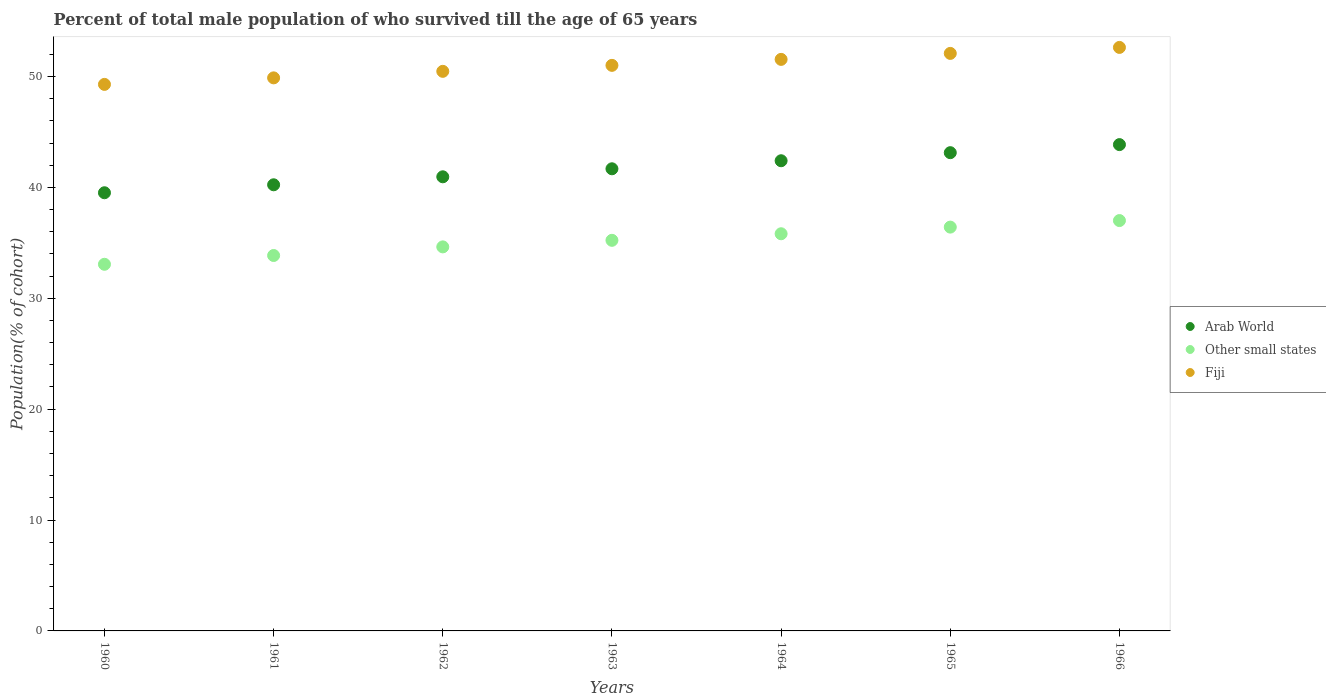Is the number of dotlines equal to the number of legend labels?
Give a very brief answer. Yes. What is the percentage of total male population who survived till the age of 65 years in Arab World in 1963?
Provide a succinct answer. 41.68. Across all years, what is the maximum percentage of total male population who survived till the age of 65 years in Arab World?
Provide a succinct answer. 43.86. Across all years, what is the minimum percentage of total male population who survived till the age of 65 years in Arab World?
Your response must be concise. 39.52. In which year was the percentage of total male population who survived till the age of 65 years in Fiji maximum?
Offer a very short reply. 1966. What is the total percentage of total male population who survived till the age of 65 years in Fiji in the graph?
Your answer should be very brief. 356.89. What is the difference between the percentage of total male population who survived till the age of 65 years in Arab World in 1965 and that in 1966?
Offer a very short reply. -0.73. What is the difference between the percentage of total male population who survived till the age of 65 years in Other small states in 1961 and the percentage of total male population who survived till the age of 65 years in Arab World in 1963?
Make the answer very short. -7.82. What is the average percentage of total male population who survived till the age of 65 years in Fiji per year?
Ensure brevity in your answer.  50.98. In the year 1963, what is the difference between the percentage of total male population who survived till the age of 65 years in Arab World and percentage of total male population who survived till the age of 65 years in Other small states?
Your response must be concise. 6.45. What is the ratio of the percentage of total male population who survived till the age of 65 years in Other small states in 1961 to that in 1965?
Make the answer very short. 0.93. Is the percentage of total male population who survived till the age of 65 years in Fiji in 1965 less than that in 1966?
Provide a short and direct response. Yes. What is the difference between the highest and the second highest percentage of total male population who survived till the age of 65 years in Arab World?
Keep it short and to the point. 0.73. What is the difference between the highest and the lowest percentage of total male population who survived till the age of 65 years in Other small states?
Keep it short and to the point. 3.94. In how many years, is the percentage of total male population who survived till the age of 65 years in Arab World greater than the average percentage of total male population who survived till the age of 65 years in Arab World taken over all years?
Make the answer very short. 3. Is the percentage of total male population who survived till the age of 65 years in Arab World strictly greater than the percentage of total male population who survived till the age of 65 years in Fiji over the years?
Ensure brevity in your answer.  No. How many dotlines are there?
Give a very brief answer. 3. What is the difference between two consecutive major ticks on the Y-axis?
Make the answer very short. 10. Are the values on the major ticks of Y-axis written in scientific E-notation?
Your answer should be compact. No. Does the graph contain any zero values?
Provide a short and direct response. No. Does the graph contain grids?
Your answer should be very brief. No. Where does the legend appear in the graph?
Your response must be concise. Center right. What is the title of the graph?
Ensure brevity in your answer.  Percent of total male population of who survived till the age of 65 years. Does "Lithuania" appear as one of the legend labels in the graph?
Provide a short and direct response. No. What is the label or title of the X-axis?
Your answer should be very brief. Years. What is the label or title of the Y-axis?
Provide a succinct answer. Population(% of cohort). What is the Population(% of cohort) of Arab World in 1960?
Offer a terse response. 39.52. What is the Population(% of cohort) of Other small states in 1960?
Provide a succinct answer. 33.07. What is the Population(% of cohort) of Fiji in 1960?
Your response must be concise. 49.29. What is the Population(% of cohort) in Arab World in 1961?
Provide a succinct answer. 40.23. What is the Population(% of cohort) of Other small states in 1961?
Provide a succinct answer. 33.86. What is the Population(% of cohort) in Fiji in 1961?
Ensure brevity in your answer.  49.88. What is the Population(% of cohort) in Arab World in 1962?
Keep it short and to the point. 40.96. What is the Population(% of cohort) in Other small states in 1962?
Make the answer very short. 34.64. What is the Population(% of cohort) in Fiji in 1962?
Keep it short and to the point. 50.47. What is the Population(% of cohort) of Arab World in 1963?
Your answer should be very brief. 41.68. What is the Population(% of cohort) of Other small states in 1963?
Offer a terse response. 35.23. What is the Population(% of cohort) in Fiji in 1963?
Ensure brevity in your answer.  51.01. What is the Population(% of cohort) of Arab World in 1964?
Keep it short and to the point. 42.4. What is the Population(% of cohort) in Other small states in 1964?
Ensure brevity in your answer.  35.82. What is the Population(% of cohort) of Fiji in 1964?
Offer a very short reply. 51.54. What is the Population(% of cohort) in Arab World in 1965?
Keep it short and to the point. 43.13. What is the Population(% of cohort) of Other small states in 1965?
Ensure brevity in your answer.  36.42. What is the Population(% of cohort) of Fiji in 1965?
Give a very brief answer. 52.08. What is the Population(% of cohort) in Arab World in 1966?
Make the answer very short. 43.86. What is the Population(% of cohort) in Other small states in 1966?
Offer a terse response. 37.01. What is the Population(% of cohort) of Fiji in 1966?
Your response must be concise. 52.62. Across all years, what is the maximum Population(% of cohort) of Arab World?
Your response must be concise. 43.86. Across all years, what is the maximum Population(% of cohort) in Other small states?
Ensure brevity in your answer.  37.01. Across all years, what is the maximum Population(% of cohort) in Fiji?
Keep it short and to the point. 52.62. Across all years, what is the minimum Population(% of cohort) of Arab World?
Your response must be concise. 39.52. Across all years, what is the minimum Population(% of cohort) in Other small states?
Provide a succinct answer. 33.07. Across all years, what is the minimum Population(% of cohort) in Fiji?
Provide a short and direct response. 49.29. What is the total Population(% of cohort) of Arab World in the graph?
Make the answer very short. 291.78. What is the total Population(% of cohort) of Other small states in the graph?
Give a very brief answer. 246.03. What is the total Population(% of cohort) of Fiji in the graph?
Make the answer very short. 356.89. What is the difference between the Population(% of cohort) in Arab World in 1960 and that in 1961?
Your answer should be compact. -0.72. What is the difference between the Population(% of cohort) in Other small states in 1960 and that in 1961?
Offer a terse response. -0.79. What is the difference between the Population(% of cohort) of Fiji in 1960 and that in 1961?
Your response must be concise. -0.59. What is the difference between the Population(% of cohort) of Arab World in 1960 and that in 1962?
Make the answer very short. -1.44. What is the difference between the Population(% of cohort) of Other small states in 1960 and that in 1962?
Your response must be concise. -1.57. What is the difference between the Population(% of cohort) of Fiji in 1960 and that in 1962?
Your answer should be compact. -1.18. What is the difference between the Population(% of cohort) of Arab World in 1960 and that in 1963?
Offer a terse response. -2.16. What is the difference between the Population(% of cohort) of Other small states in 1960 and that in 1963?
Make the answer very short. -2.16. What is the difference between the Population(% of cohort) of Fiji in 1960 and that in 1963?
Keep it short and to the point. -1.72. What is the difference between the Population(% of cohort) in Arab World in 1960 and that in 1964?
Offer a very short reply. -2.89. What is the difference between the Population(% of cohort) in Other small states in 1960 and that in 1964?
Provide a succinct answer. -2.75. What is the difference between the Population(% of cohort) of Fiji in 1960 and that in 1964?
Provide a short and direct response. -2.26. What is the difference between the Population(% of cohort) of Arab World in 1960 and that in 1965?
Make the answer very short. -3.61. What is the difference between the Population(% of cohort) in Other small states in 1960 and that in 1965?
Your answer should be compact. -3.35. What is the difference between the Population(% of cohort) of Fiji in 1960 and that in 1965?
Your answer should be very brief. -2.8. What is the difference between the Population(% of cohort) in Arab World in 1960 and that in 1966?
Your answer should be very brief. -4.34. What is the difference between the Population(% of cohort) of Other small states in 1960 and that in 1966?
Offer a very short reply. -3.94. What is the difference between the Population(% of cohort) of Fiji in 1960 and that in 1966?
Give a very brief answer. -3.33. What is the difference between the Population(% of cohort) in Arab World in 1961 and that in 1962?
Keep it short and to the point. -0.72. What is the difference between the Population(% of cohort) of Other small states in 1961 and that in 1962?
Keep it short and to the point. -0.78. What is the difference between the Population(% of cohort) of Fiji in 1961 and that in 1962?
Offer a very short reply. -0.59. What is the difference between the Population(% of cohort) in Arab World in 1961 and that in 1963?
Your response must be concise. -1.44. What is the difference between the Population(% of cohort) in Other small states in 1961 and that in 1963?
Your response must be concise. -1.37. What is the difference between the Population(% of cohort) in Fiji in 1961 and that in 1963?
Your response must be concise. -1.13. What is the difference between the Population(% of cohort) of Arab World in 1961 and that in 1964?
Make the answer very short. -2.17. What is the difference between the Population(% of cohort) in Other small states in 1961 and that in 1964?
Your response must be concise. -1.96. What is the difference between the Population(% of cohort) in Fiji in 1961 and that in 1964?
Your answer should be compact. -1.67. What is the difference between the Population(% of cohort) of Arab World in 1961 and that in 1965?
Your response must be concise. -2.9. What is the difference between the Population(% of cohort) in Other small states in 1961 and that in 1965?
Keep it short and to the point. -2.56. What is the difference between the Population(% of cohort) of Fiji in 1961 and that in 1965?
Your answer should be compact. -2.21. What is the difference between the Population(% of cohort) in Arab World in 1961 and that in 1966?
Give a very brief answer. -3.62. What is the difference between the Population(% of cohort) of Other small states in 1961 and that in 1966?
Your answer should be compact. -3.15. What is the difference between the Population(% of cohort) of Fiji in 1961 and that in 1966?
Your answer should be compact. -2.75. What is the difference between the Population(% of cohort) of Arab World in 1962 and that in 1963?
Your answer should be compact. -0.72. What is the difference between the Population(% of cohort) of Other small states in 1962 and that in 1963?
Offer a terse response. -0.59. What is the difference between the Population(% of cohort) of Fiji in 1962 and that in 1963?
Provide a short and direct response. -0.54. What is the difference between the Population(% of cohort) of Arab World in 1962 and that in 1964?
Offer a very short reply. -1.45. What is the difference between the Population(% of cohort) of Other small states in 1962 and that in 1964?
Keep it short and to the point. -1.18. What is the difference between the Population(% of cohort) of Fiji in 1962 and that in 1964?
Provide a short and direct response. -1.08. What is the difference between the Population(% of cohort) of Arab World in 1962 and that in 1965?
Your response must be concise. -2.18. What is the difference between the Population(% of cohort) in Other small states in 1962 and that in 1965?
Ensure brevity in your answer.  -1.78. What is the difference between the Population(% of cohort) of Fiji in 1962 and that in 1965?
Your answer should be compact. -1.62. What is the difference between the Population(% of cohort) in Arab World in 1962 and that in 1966?
Offer a terse response. -2.9. What is the difference between the Population(% of cohort) in Other small states in 1962 and that in 1966?
Your response must be concise. -2.37. What is the difference between the Population(% of cohort) of Fiji in 1962 and that in 1966?
Your answer should be very brief. -2.16. What is the difference between the Population(% of cohort) in Arab World in 1963 and that in 1964?
Your response must be concise. -0.72. What is the difference between the Population(% of cohort) of Other small states in 1963 and that in 1964?
Provide a short and direct response. -0.59. What is the difference between the Population(% of cohort) of Fiji in 1963 and that in 1964?
Offer a terse response. -0.54. What is the difference between the Population(% of cohort) of Arab World in 1963 and that in 1965?
Provide a succinct answer. -1.45. What is the difference between the Population(% of cohort) in Other small states in 1963 and that in 1965?
Make the answer very short. -1.19. What is the difference between the Population(% of cohort) in Fiji in 1963 and that in 1965?
Ensure brevity in your answer.  -1.08. What is the difference between the Population(% of cohort) in Arab World in 1963 and that in 1966?
Your response must be concise. -2.18. What is the difference between the Population(% of cohort) of Other small states in 1963 and that in 1966?
Your response must be concise. -1.78. What is the difference between the Population(% of cohort) of Fiji in 1963 and that in 1966?
Provide a short and direct response. -1.62. What is the difference between the Population(% of cohort) of Arab World in 1964 and that in 1965?
Make the answer very short. -0.73. What is the difference between the Population(% of cohort) of Other small states in 1964 and that in 1965?
Make the answer very short. -0.6. What is the difference between the Population(% of cohort) in Fiji in 1964 and that in 1965?
Your answer should be very brief. -0.54. What is the difference between the Population(% of cohort) of Arab World in 1964 and that in 1966?
Provide a succinct answer. -1.46. What is the difference between the Population(% of cohort) of Other small states in 1964 and that in 1966?
Make the answer very short. -1.19. What is the difference between the Population(% of cohort) of Fiji in 1964 and that in 1966?
Provide a succinct answer. -1.08. What is the difference between the Population(% of cohort) in Arab World in 1965 and that in 1966?
Your response must be concise. -0.73. What is the difference between the Population(% of cohort) of Other small states in 1965 and that in 1966?
Offer a very short reply. -0.59. What is the difference between the Population(% of cohort) of Fiji in 1965 and that in 1966?
Your answer should be compact. -0.54. What is the difference between the Population(% of cohort) in Arab World in 1960 and the Population(% of cohort) in Other small states in 1961?
Make the answer very short. 5.66. What is the difference between the Population(% of cohort) in Arab World in 1960 and the Population(% of cohort) in Fiji in 1961?
Offer a terse response. -10.36. What is the difference between the Population(% of cohort) in Other small states in 1960 and the Population(% of cohort) in Fiji in 1961?
Make the answer very short. -16.81. What is the difference between the Population(% of cohort) in Arab World in 1960 and the Population(% of cohort) in Other small states in 1962?
Your answer should be compact. 4.88. What is the difference between the Population(% of cohort) of Arab World in 1960 and the Population(% of cohort) of Fiji in 1962?
Give a very brief answer. -10.95. What is the difference between the Population(% of cohort) in Other small states in 1960 and the Population(% of cohort) in Fiji in 1962?
Your answer should be very brief. -17.4. What is the difference between the Population(% of cohort) of Arab World in 1960 and the Population(% of cohort) of Other small states in 1963?
Make the answer very short. 4.29. What is the difference between the Population(% of cohort) of Arab World in 1960 and the Population(% of cohort) of Fiji in 1963?
Ensure brevity in your answer.  -11.49. What is the difference between the Population(% of cohort) of Other small states in 1960 and the Population(% of cohort) of Fiji in 1963?
Make the answer very short. -17.94. What is the difference between the Population(% of cohort) of Arab World in 1960 and the Population(% of cohort) of Other small states in 1964?
Make the answer very short. 3.7. What is the difference between the Population(% of cohort) of Arab World in 1960 and the Population(% of cohort) of Fiji in 1964?
Give a very brief answer. -12.03. What is the difference between the Population(% of cohort) in Other small states in 1960 and the Population(% of cohort) in Fiji in 1964?
Make the answer very short. -18.48. What is the difference between the Population(% of cohort) of Arab World in 1960 and the Population(% of cohort) of Other small states in 1965?
Your answer should be very brief. 3.1. What is the difference between the Population(% of cohort) of Arab World in 1960 and the Population(% of cohort) of Fiji in 1965?
Provide a short and direct response. -12.57. What is the difference between the Population(% of cohort) in Other small states in 1960 and the Population(% of cohort) in Fiji in 1965?
Your answer should be compact. -19.02. What is the difference between the Population(% of cohort) of Arab World in 1960 and the Population(% of cohort) of Other small states in 1966?
Offer a terse response. 2.51. What is the difference between the Population(% of cohort) of Arab World in 1960 and the Population(% of cohort) of Fiji in 1966?
Keep it short and to the point. -13.11. What is the difference between the Population(% of cohort) of Other small states in 1960 and the Population(% of cohort) of Fiji in 1966?
Offer a terse response. -19.56. What is the difference between the Population(% of cohort) of Arab World in 1961 and the Population(% of cohort) of Other small states in 1962?
Offer a very short reply. 5.6. What is the difference between the Population(% of cohort) in Arab World in 1961 and the Population(% of cohort) in Fiji in 1962?
Provide a succinct answer. -10.23. What is the difference between the Population(% of cohort) of Other small states in 1961 and the Population(% of cohort) of Fiji in 1962?
Your response must be concise. -16.61. What is the difference between the Population(% of cohort) in Arab World in 1961 and the Population(% of cohort) in Other small states in 1963?
Your answer should be very brief. 5.01. What is the difference between the Population(% of cohort) of Arab World in 1961 and the Population(% of cohort) of Fiji in 1963?
Your answer should be compact. -10.77. What is the difference between the Population(% of cohort) of Other small states in 1961 and the Population(% of cohort) of Fiji in 1963?
Keep it short and to the point. -17.15. What is the difference between the Population(% of cohort) in Arab World in 1961 and the Population(% of cohort) in Other small states in 1964?
Make the answer very short. 4.42. What is the difference between the Population(% of cohort) in Arab World in 1961 and the Population(% of cohort) in Fiji in 1964?
Your answer should be compact. -11.31. What is the difference between the Population(% of cohort) of Other small states in 1961 and the Population(% of cohort) of Fiji in 1964?
Provide a short and direct response. -17.69. What is the difference between the Population(% of cohort) of Arab World in 1961 and the Population(% of cohort) of Other small states in 1965?
Your response must be concise. 3.82. What is the difference between the Population(% of cohort) of Arab World in 1961 and the Population(% of cohort) of Fiji in 1965?
Keep it short and to the point. -11.85. What is the difference between the Population(% of cohort) in Other small states in 1961 and the Population(% of cohort) in Fiji in 1965?
Offer a very short reply. -18.23. What is the difference between the Population(% of cohort) in Arab World in 1961 and the Population(% of cohort) in Other small states in 1966?
Offer a terse response. 3.23. What is the difference between the Population(% of cohort) in Arab World in 1961 and the Population(% of cohort) in Fiji in 1966?
Provide a succinct answer. -12.39. What is the difference between the Population(% of cohort) of Other small states in 1961 and the Population(% of cohort) of Fiji in 1966?
Offer a very short reply. -18.77. What is the difference between the Population(% of cohort) in Arab World in 1962 and the Population(% of cohort) in Other small states in 1963?
Offer a very short reply. 5.73. What is the difference between the Population(% of cohort) in Arab World in 1962 and the Population(% of cohort) in Fiji in 1963?
Your answer should be compact. -10.05. What is the difference between the Population(% of cohort) of Other small states in 1962 and the Population(% of cohort) of Fiji in 1963?
Your answer should be compact. -16.37. What is the difference between the Population(% of cohort) of Arab World in 1962 and the Population(% of cohort) of Other small states in 1964?
Ensure brevity in your answer.  5.14. What is the difference between the Population(% of cohort) of Arab World in 1962 and the Population(% of cohort) of Fiji in 1964?
Make the answer very short. -10.59. What is the difference between the Population(% of cohort) in Other small states in 1962 and the Population(% of cohort) in Fiji in 1964?
Provide a succinct answer. -16.91. What is the difference between the Population(% of cohort) in Arab World in 1962 and the Population(% of cohort) in Other small states in 1965?
Your answer should be very brief. 4.54. What is the difference between the Population(% of cohort) in Arab World in 1962 and the Population(% of cohort) in Fiji in 1965?
Ensure brevity in your answer.  -11.13. What is the difference between the Population(% of cohort) in Other small states in 1962 and the Population(% of cohort) in Fiji in 1965?
Keep it short and to the point. -17.45. What is the difference between the Population(% of cohort) of Arab World in 1962 and the Population(% of cohort) of Other small states in 1966?
Ensure brevity in your answer.  3.95. What is the difference between the Population(% of cohort) of Arab World in 1962 and the Population(% of cohort) of Fiji in 1966?
Give a very brief answer. -11.67. What is the difference between the Population(% of cohort) in Other small states in 1962 and the Population(% of cohort) in Fiji in 1966?
Give a very brief answer. -17.99. What is the difference between the Population(% of cohort) of Arab World in 1963 and the Population(% of cohort) of Other small states in 1964?
Offer a terse response. 5.86. What is the difference between the Population(% of cohort) in Arab World in 1963 and the Population(% of cohort) in Fiji in 1964?
Your response must be concise. -9.87. What is the difference between the Population(% of cohort) of Other small states in 1963 and the Population(% of cohort) of Fiji in 1964?
Your response must be concise. -16.32. What is the difference between the Population(% of cohort) of Arab World in 1963 and the Population(% of cohort) of Other small states in 1965?
Provide a succinct answer. 5.26. What is the difference between the Population(% of cohort) in Arab World in 1963 and the Population(% of cohort) in Fiji in 1965?
Your response must be concise. -10.41. What is the difference between the Population(% of cohort) in Other small states in 1963 and the Population(% of cohort) in Fiji in 1965?
Your answer should be very brief. -16.86. What is the difference between the Population(% of cohort) of Arab World in 1963 and the Population(% of cohort) of Other small states in 1966?
Give a very brief answer. 4.67. What is the difference between the Population(% of cohort) in Arab World in 1963 and the Population(% of cohort) in Fiji in 1966?
Make the answer very short. -10.95. What is the difference between the Population(% of cohort) in Other small states in 1963 and the Population(% of cohort) in Fiji in 1966?
Make the answer very short. -17.4. What is the difference between the Population(% of cohort) in Arab World in 1964 and the Population(% of cohort) in Other small states in 1965?
Your answer should be very brief. 5.99. What is the difference between the Population(% of cohort) of Arab World in 1964 and the Population(% of cohort) of Fiji in 1965?
Provide a succinct answer. -9.68. What is the difference between the Population(% of cohort) in Other small states in 1964 and the Population(% of cohort) in Fiji in 1965?
Keep it short and to the point. -16.27. What is the difference between the Population(% of cohort) of Arab World in 1964 and the Population(% of cohort) of Other small states in 1966?
Provide a succinct answer. 5.39. What is the difference between the Population(% of cohort) of Arab World in 1964 and the Population(% of cohort) of Fiji in 1966?
Offer a terse response. -10.22. What is the difference between the Population(% of cohort) of Other small states in 1964 and the Population(% of cohort) of Fiji in 1966?
Your answer should be compact. -16.81. What is the difference between the Population(% of cohort) of Arab World in 1965 and the Population(% of cohort) of Other small states in 1966?
Offer a terse response. 6.12. What is the difference between the Population(% of cohort) in Arab World in 1965 and the Population(% of cohort) in Fiji in 1966?
Your response must be concise. -9.49. What is the difference between the Population(% of cohort) in Other small states in 1965 and the Population(% of cohort) in Fiji in 1966?
Your answer should be very brief. -16.21. What is the average Population(% of cohort) in Arab World per year?
Your answer should be compact. 41.68. What is the average Population(% of cohort) of Other small states per year?
Give a very brief answer. 35.15. What is the average Population(% of cohort) in Fiji per year?
Offer a terse response. 50.98. In the year 1960, what is the difference between the Population(% of cohort) in Arab World and Population(% of cohort) in Other small states?
Give a very brief answer. 6.45. In the year 1960, what is the difference between the Population(% of cohort) in Arab World and Population(% of cohort) in Fiji?
Make the answer very short. -9.77. In the year 1960, what is the difference between the Population(% of cohort) in Other small states and Population(% of cohort) in Fiji?
Your response must be concise. -16.22. In the year 1961, what is the difference between the Population(% of cohort) in Arab World and Population(% of cohort) in Other small states?
Your answer should be compact. 6.38. In the year 1961, what is the difference between the Population(% of cohort) in Arab World and Population(% of cohort) in Fiji?
Your answer should be compact. -9.64. In the year 1961, what is the difference between the Population(% of cohort) in Other small states and Population(% of cohort) in Fiji?
Provide a short and direct response. -16.02. In the year 1962, what is the difference between the Population(% of cohort) of Arab World and Population(% of cohort) of Other small states?
Give a very brief answer. 6.32. In the year 1962, what is the difference between the Population(% of cohort) of Arab World and Population(% of cohort) of Fiji?
Make the answer very short. -9.51. In the year 1962, what is the difference between the Population(% of cohort) of Other small states and Population(% of cohort) of Fiji?
Give a very brief answer. -15.83. In the year 1963, what is the difference between the Population(% of cohort) of Arab World and Population(% of cohort) of Other small states?
Give a very brief answer. 6.45. In the year 1963, what is the difference between the Population(% of cohort) in Arab World and Population(% of cohort) in Fiji?
Make the answer very short. -9.33. In the year 1963, what is the difference between the Population(% of cohort) in Other small states and Population(% of cohort) in Fiji?
Provide a succinct answer. -15.78. In the year 1964, what is the difference between the Population(% of cohort) of Arab World and Population(% of cohort) of Other small states?
Your response must be concise. 6.58. In the year 1964, what is the difference between the Population(% of cohort) in Arab World and Population(% of cohort) in Fiji?
Keep it short and to the point. -9.14. In the year 1964, what is the difference between the Population(% of cohort) in Other small states and Population(% of cohort) in Fiji?
Your response must be concise. -15.73. In the year 1965, what is the difference between the Population(% of cohort) of Arab World and Population(% of cohort) of Other small states?
Keep it short and to the point. 6.71. In the year 1965, what is the difference between the Population(% of cohort) in Arab World and Population(% of cohort) in Fiji?
Offer a terse response. -8.95. In the year 1965, what is the difference between the Population(% of cohort) of Other small states and Population(% of cohort) of Fiji?
Make the answer very short. -15.67. In the year 1966, what is the difference between the Population(% of cohort) in Arab World and Population(% of cohort) in Other small states?
Offer a very short reply. 6.85. In the year 1966, what is the difference between the Population(% of cohort) of Arab World and Population(% of cohort) of Fiji?
Provide a succinct answer. -8.77. In the year 1966, what is the difference between the Population(% of cohort) of Other small states and Population(% of cohort) of Fiji?
Ensure brevity in your answer.  -15.62. What is the ratio of the Population(% of cohort) of Arab World in 1960 to that in 1961?
Offer a very short reply. 0.98. What is the ratio of the Population(% of cohort) in Other small states in 1960 to that in 1961?
Offer a very short reply. 0.98. What is the ratio of the Population(% of cohort) in Arab World in 1960 to that in 1962?
Keep it short and to the point. 0.96. What is the ratio of the Population(% of cohort) in Other small states in 1960 to that in 1962?
Keep it short and to the point. 0.95. What is the ratio of the Population(% of cohort) in Fiji in 1960 to that in 1962?
Make the answer very short. 0.98. What is the ratio of the Population(% of cohort) of Arab World in 1960 to that in 1963?
Make the answer very short. 0.95. What is the ratio of the Population(% of cohort) of Other small states in 1960 to that in 1963?
Ensure brevity in your answer.  0.94. What is the ratio of the Population(% of cohort) of Fiji in 1960 to that in 1963?
Your response must be concise. 0.97. What is the ratio of the Population(% of cohort) of Arab World in 1960 to that in 1964?
Provide a short and direct response. 0.93. What is the ratio of the Population(% of cohort) of Other small states in 1960 to that in 1964?
Your answer should be compact. 0.92. What is the ratio of the Population(% of cohort) in Fiji in 1960 to that in 1964?
Offer a very short reply. 0.96. What is the ratio of the Population(% of cohort) in Arab World in 1960 to that in 1965?
Offer a terse response. 0.92. What is the ratio of the Population(% of cohort) of Other small states in 1960 to that in 1965?
Your answer should be very brief. 0.91. What is the ratio of the Population(% of cohort) in Fiji in 1960 to that in 1965?
Offer a terse response. 0.95. What is the ratio of the Population(% of cohort) of Arab World in 1960 to that in 1966?
Keep it short and to the point. 0.9. What is the ratio of the Population(% of cohort) of Other small states in 1960 to that in 1966?
Your answer should be compact. 0.89. What is the ratio of the Population(% of cohort) in Fiji in 1960 to that in 1966?
Ensure brevity in your answer.  0.94. What is the ratio of the Population(% of cohort) of Arab World in 1961 to that in 1962?
Provide a succinct answer. 0.98. What is the ratio of the Population(% of cohort) of Other small states in 1961 to that in 1962?
Provide a short and direct response. 0.98. What is the ratio of the Population(% of cohort) of Fiji in 1961 to that in 1962?
Provide a succinct answer. 0.99. What is the ratio of the Population(% of cohort) of Arab World in 1961 to that in 1963?
Your answer should be compact. 0.97. What is the ratio of the Population(% of cohort) in Other small states in 1961 to that in 1963?
Give a very brief answer. 0.96. What is the ratio of the Population(% of cohort) of Fiji in 1961 to that in 1963?
Offer a terse response. 0.98. What is the ratio of the Population(% of cohort) in Arab World in 1961 to that in 1964?
Make the answer very short. 0.95. What is the ratio of the Population(% of cohort) in Other small states in 1961 to that in 1964?
Make the answer very short. 0.95. What is the ratio of the Population(% of cohort) in Fiji in 1961 to that in 1964?
Offer a terse response. 0.97. What is the ratio of the Population(% of cohort) of Arab World in 1961 to that in 1965?
Make the answer very short. 0.93. What is the ratio of the Population(% of cohort) of Other small states in 1961 to that in 1965?
Give a very brief answer. 0.93. What is the ratio of the Population(% of cohort) of Fiji in 1961 to that in 1965?
Make the answer very short. 0.96. What is the ratio of the Population(% of cohort) in Arab World in 1961 to that in 1966?
Keep it short and to the point. 0.92. What is the ratio of the Population(% of cohort) of Other small states in 1961 to that in 1966?
Ensure brevity in your answer.  0.91. What is the ratio of the Population(% of cohort) of Fiji in 1961 to that in 1966?
Make the answer very short. 0.95. What is the ratio of the Population(% of cohort) in Arab World in 1962 to that in 1963?
Ensure brevity in your answer.  0.98. What is the ratio of the Population(% of cohort) in Other small states in 1962 to that in 1963?
Offer a terse response. 0.98. What is the ratio of the Population(% of cohort) of Arab World in 1962 to that in 1964?
Offer a very short reply. 0.97. What is the ratio of the Population(% of cohort) of Other small states in 1962 to that in 1964?
Make the answer very short. 0.97. What is the ratio of the Population(% of cohort) in Fiji in 1962 to that in 1964?
Your response must be concise. 0.98. What is the ratio of the Population(% of cohort) of Arab World in 1962 to that in 1965?
Your answer should be very brief. 0.95. What is the ratio of the Population(% of cohort) in Other small states in 1962 to that in 1965?
Offer a terse response. 0.95. What is the ratio of the Population(% of cohort) of Fiji in 1962 to that in 1965?
Give a very brief answer. 0.97. What is the ratio of the Population(% of cohort) in Arab World in 1962 to that in 1966?
Give a very brief answer. 0.93. What is the ratio of the Population(% of cohort) in Other small states in 1962 to that in 1966?
Ensure brevity in your answer.  0.94. What is the ratio of the Population(% of cohort) of Arab World in 1963 to that in 1964?
Provide a succinct answer. 0.98. What is the ratio of the Population(% of cohort) in Other small states in 1963 to that in 1964?
Your answer should be very brief. 0.98. What is the ratio of the Population(% of cohort) in Arab World in 1963 to that in 1965?
Provide a short and direct response. 0.97. What is the ratio of the Population(% of cohort) of Other small states in 1963 to that in 1965?
Your answer should be compact. 0.97. What is the ratio of the Population(% of cohort) of Fiji in 1963 to that in 1965?
Provide a short and direct response. 0.98. What is the ratio of the Population(% of cohort) in Arab World in 1963 to that in 1966?
Ensure brevity in your answer.  0.95. What is the ratio of the Population(% of cohort) in Other small states in 1963 to that in 1966?
Keep it short and to the point. 0.95. What is the ratio of the Population(% of cohort) in Fiji in 1963 to that in 1966?
Offer a very short reply. 0.97. What is the ratio of the Population(% of cohort) of Arab World in 1964 to that in 1965?
Make the answer very short. 0.98. What is the ratio of the Population(% of cohort) of Other small states in 1964 to that in 1965?
Your answer should be very brief. 0.98. What is the ratio of the Population(% of cohort) in Arab World in 1964 to that in 1966?
Keep it short and to the point. 0.97. What is the ratio of the Population(% of cohort) in Other small states in 1964 to that in 1966?
Give a very brief answer. 0.97. What is the ratio of the Population(% of cohort) in Fiji in 1964 to that in 1966?
Ensure brevity in your answer.  0.98. What is the ratio of the Population(% of cohort) of Arab World in 1965 to that in 1966?
Keep it short and to the point. 0.98. What is the ratio of the Population(% of cohort) in Fiji in 1965 to that in 1966?
Keep it short and to the point. 0.99. What is the difference between the highest and the second highest Population(% of cohort) of Arab World?
Keep it short and to the point. 0.73. What is the difference between the highest and the second highest Population(% of cohort) of Other small states?
Provide a succinct answer. 0.59. What is the difference between the highest and the second highest Population(% of cohort) of Fiji?
Provide a short and direct response. 0.54. What is the difference between the highest and the lowest Population(% of cohort) of Arab World?
Ensure brevity in your answer.  4.34. What is the difference between the highest and the lowest Population(% of cohort) in Other small states?
Provide a short and direct response. 3.94. What is the difference between the highest and the lowest Population(% of cohort) in Fiji?
Provide a succinct answer. 3.33. 